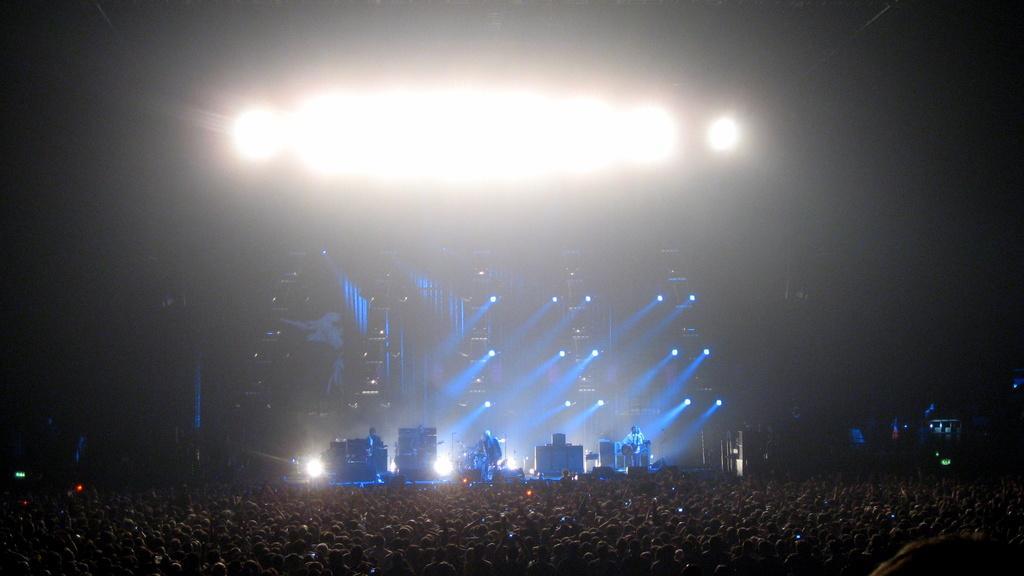Can you describe this image briefly? In this image in front there are people. In the background of the image there are people playing musical instruments. There are lights. 